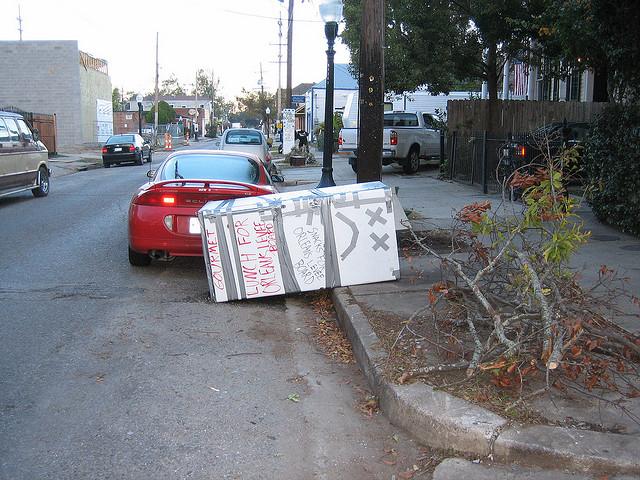Is the brake pedal being pressed?
Keep it brief. Yes. What color car is behind the box?
Concise answer only. Red. Are the tail lights of the red car on?
Write a very short answer. Yes. 